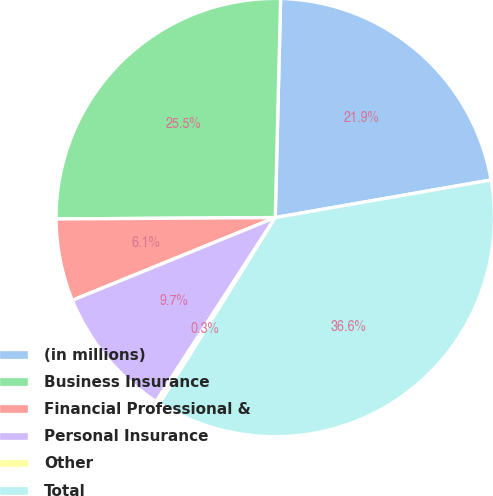Convert chart. <chart><loc_0><loc_0><loc_500><loc_500><pie_chart><fcel>(in millions)<fcel>Business Insurance<fcel>Financial Professional &<fcel>Personal Insurance<fcel>Other<fcel>Total<nl><fcel>21.86%<fcel>25.49%<fcel>6.06%<fcel>9.69%<fcel>0.29%<fcel>36.6%<nl></chart> 